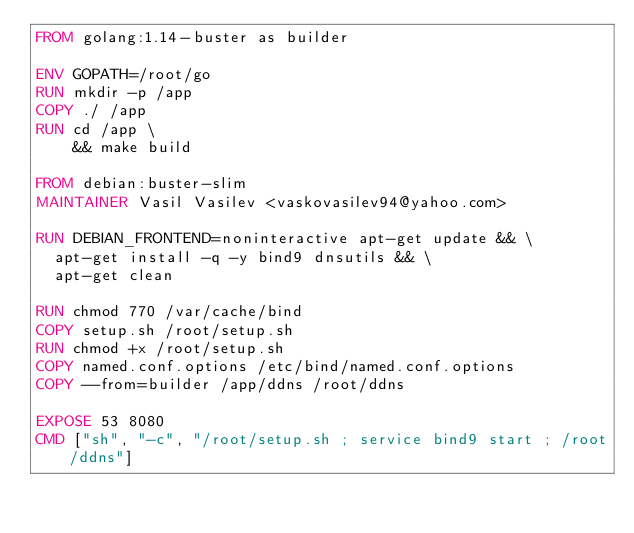<code> <loc_0><loc_0><loc_500><loc_500><_Dockerfile_>FROM golang:1.14-buster as builder

ENV GOPATH=/root/go
RUN mkdir -p /app
COPY ./ /app
RUN cd /app \
    && make build

FROM debian:buster-slim
MAINTAINER Vasil Vasilev <vaskovasilev94@yahoo.com>

RUN DEBIAN_FRONTEND=noninteractive apt-get update && \
	apt-get install -q -y bind9 dnsutils && \
	apt-get clean

RUN chmod 770 /var/cache/bind
COPY setup.sh /root/setup.sh
RUN chmod +x /root/setup.sh
COPY named.conf.options /etc/bind/named.conf.options
COPY --from=builder /app/ddns /root/ddns

EXPOSE 53 8080
CMD ["sh", "-c", "/root/setup.sh ; service bind9 start ; /root/ddns"]
</code> 